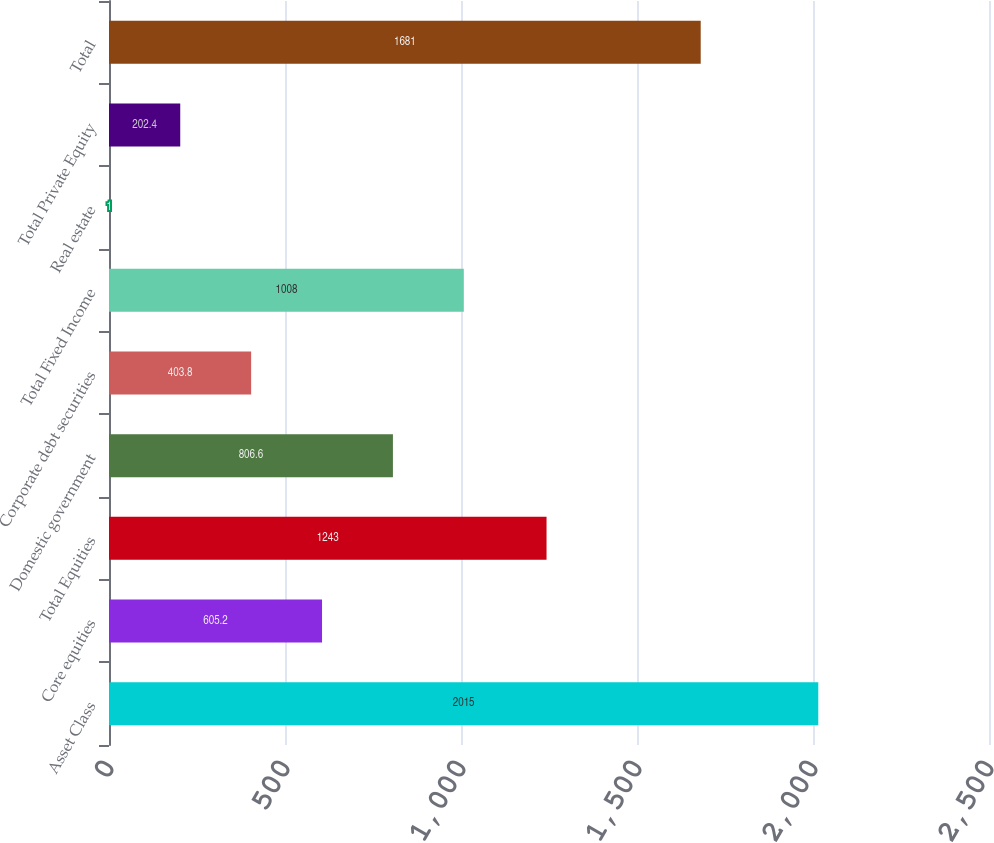Convert chart to OTSL. <chart><loc_0><loc_0><loc_500><loc_500><bar_chart><fcel>Asset Class<fcel>Core equities<fcel>Total Equities<fcel>Domestic government<fcel>Corporate debt securities<fcel>Total Fixed Income<fcel>Real estate<fcel>Total Private Equity<fcel>Total<nl><fcel>2015<fcel>605.2<fcel>1243<fcel>806.6<fcel>403.8<fcel>1008<fcel>1<fcel>202.4<fcel>1681<nl></chart> 